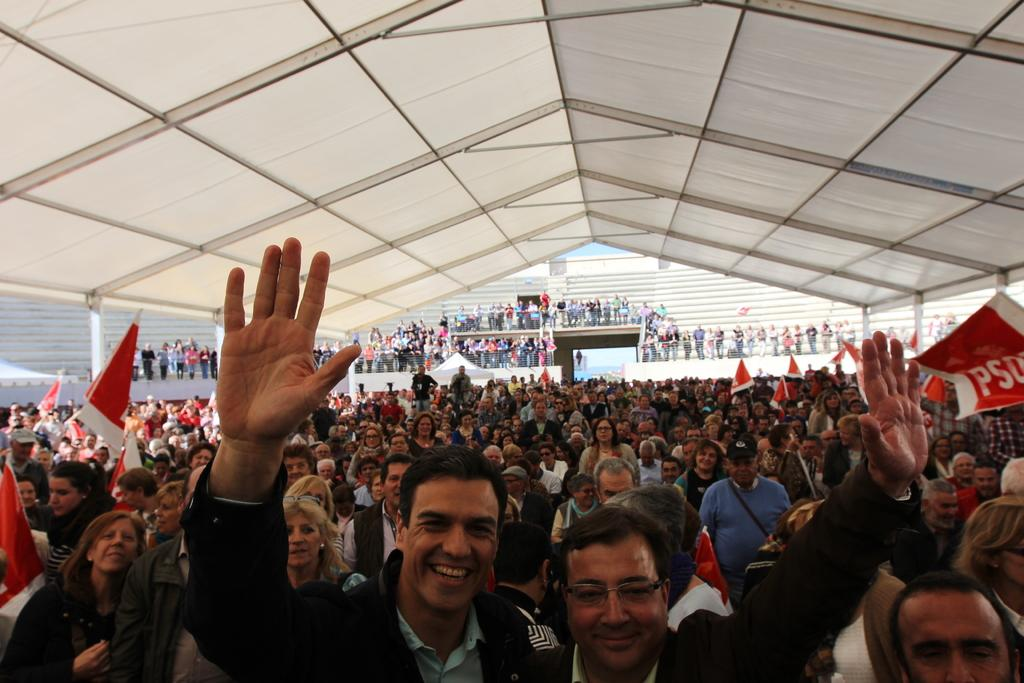What can be seen in the image? There are people in the image. What are some of the people holding? Some of the people are holding flags and some are holding placards. What is written on the placards? There is text on the placards. What can be seen in the background of the image? The sky is visible in the image. Can you describe the secretary's trousers in the image? There is no secretary or trousers mentioned in the image; it features people holding flags and placards. Are there any goldfish visible in the image? There are no goldfish present in the image. 